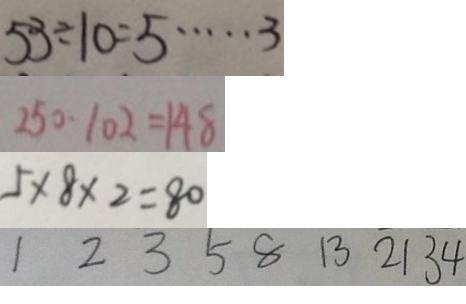<formula> <loc_0><loc_0><loc_500><loc_500>5 3 \div 1 0 = 5 \cdots 3 
 2 5 0 - 1 0 2 = 1 4 8 
 5 \times 8 \times 2 = 8 0 
 1 2 3 5 8 1 3 2 1 3 4</formula> 